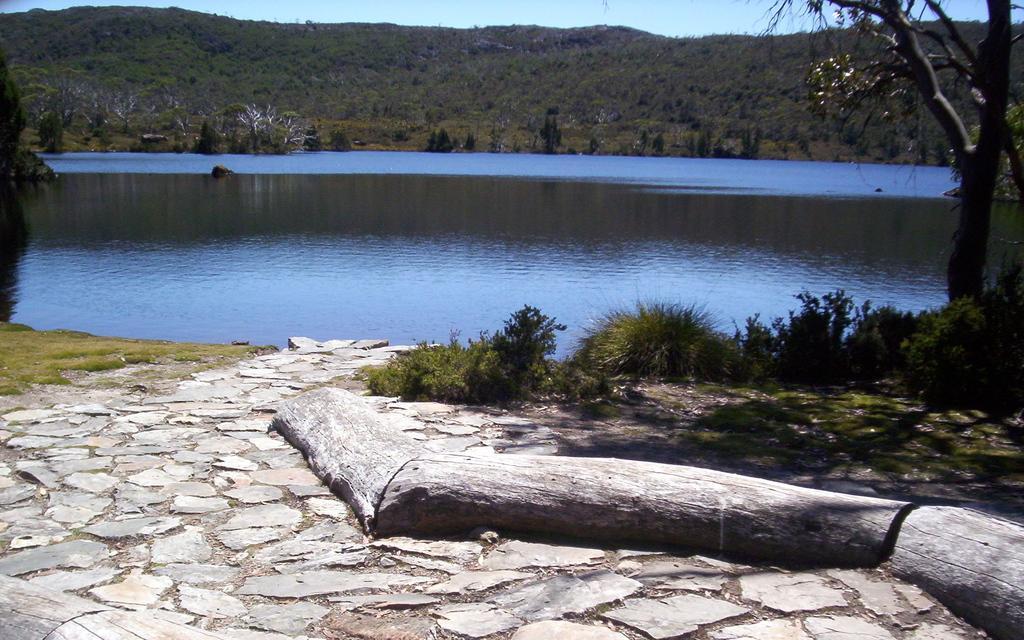Describe this image in one or two sentences. In this image I can see few trees, grass, water and mountains. The sky is in blue color. 